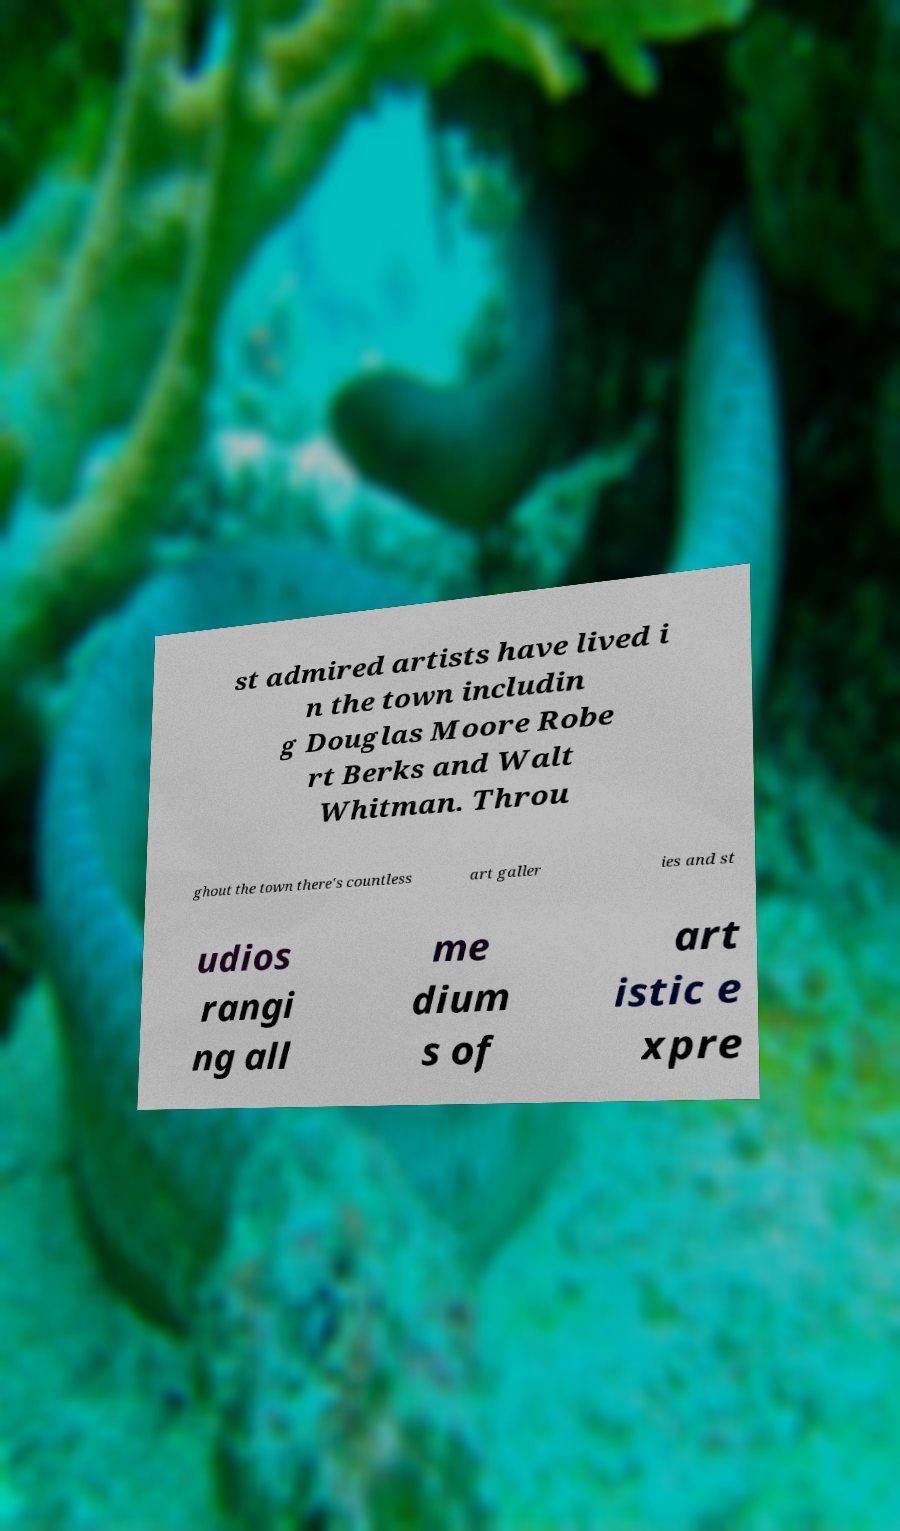Please identify and transcribe the text found in this image. st admired artists have lived i n the town includin g Douglas Moore Robe rt Berks and Walt Whitman. Throu ghout the town there's countless art galler ies and st udios rangi ng all me dium s of art istic e xpre 